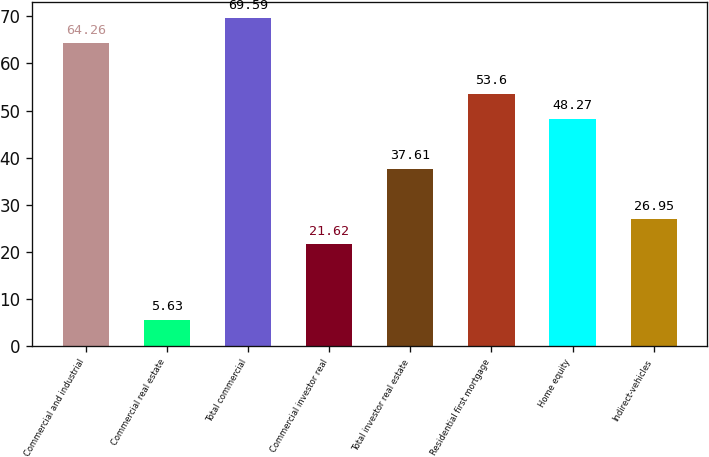Convert chart. <chart><loc_0><loc_0><loc_500><loc_500><bar_chart><fcel>Commercial and industrial<fcel>Commercial real estate<fcel>Total commercial<fcel>Commercial investor real<fcel>Total investor real estate<fcel>Residential first mortgage<fcel>Home equity<fcel>Indirect-vehicles<nl><fcel>64.26<fcel>5.63<fcel>69.59<fcel>21.62<fcel>37.61<fcel>53.6<fcel>48.27<fcel>26.95<nl></chart> 